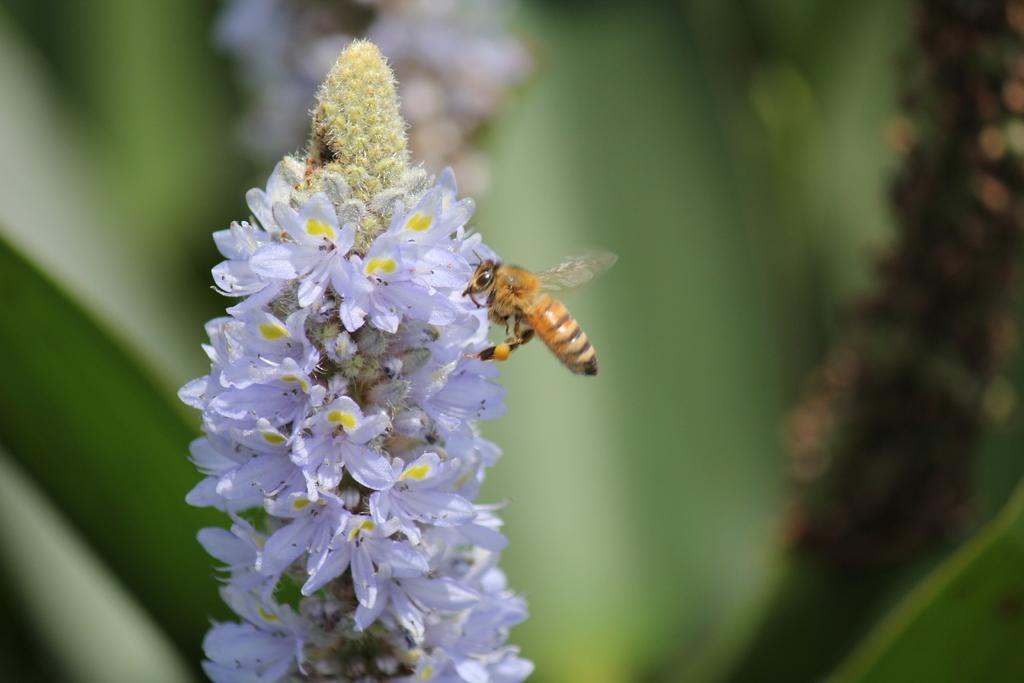Can you describe this image briefly? In this image we can see an insect on the flowers. In the background the image is blur but we can see objects. 